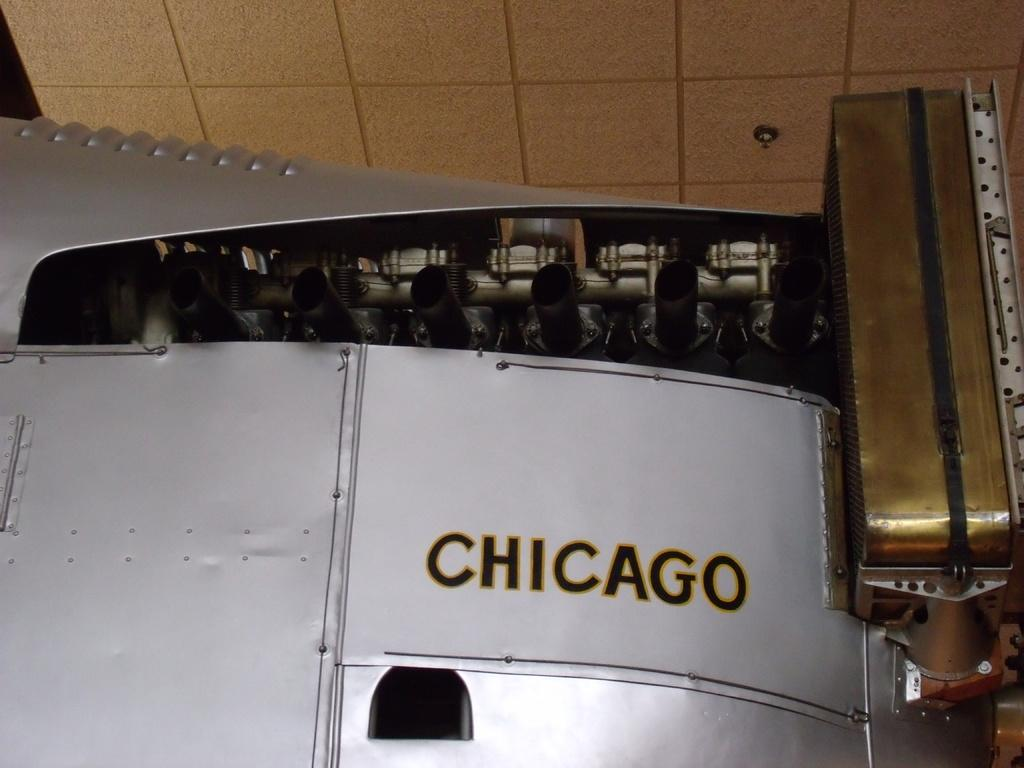<image>
Relay a brief, clear account of the picture shown. A large piece of white metal with a lot of piping and the word Chicago painted on the side. 